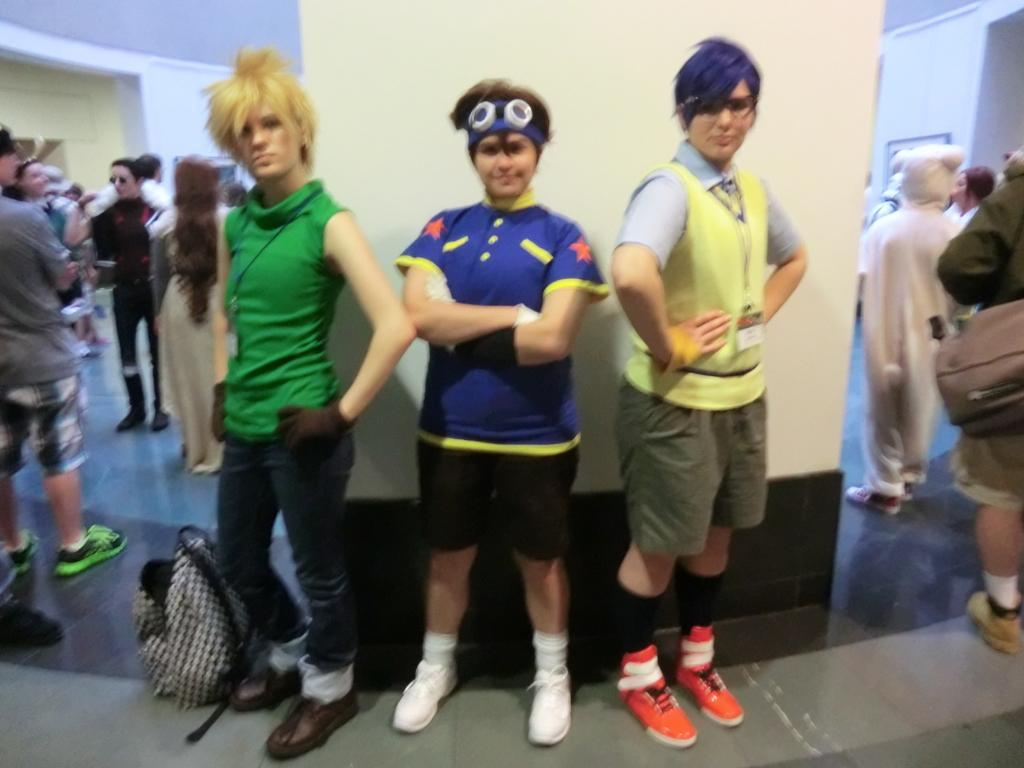Please provide a concise description of this image. In this image I can see three people standing in the center of the image and posing for the picture, I can see a pillar behind them. I can see a group of people on the right and left sides of the image. 